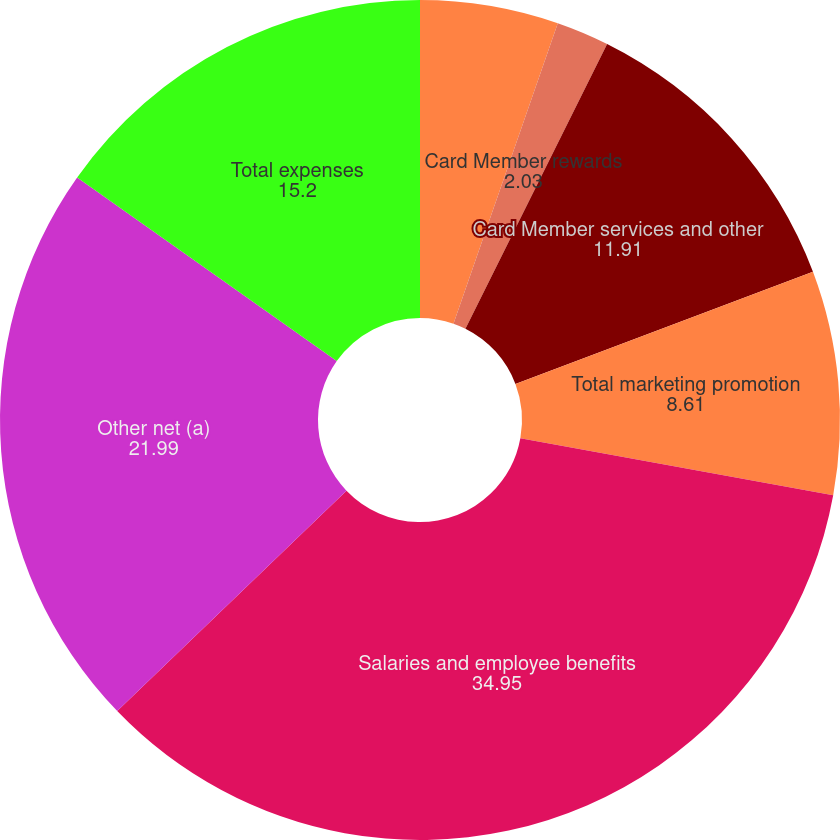Convert chart. <chart><loc_0><loc_0><loc_500><loc_500><pie_chart><fcel>Marketing and promotion<fcel>Card Member rewards<fcel>Card Member services and other<fcel>Total marketing promotion<fcel>Salaries and employee benefits<fcel>Other net (a)<fcel>Total expenses<nl><fcel>5.32%<fcel>2.03%<fcel>11.91%<fcel>8.61%<fcel>34.95%<fcel>21.99%<fcel>15.2%<nl></chart> 